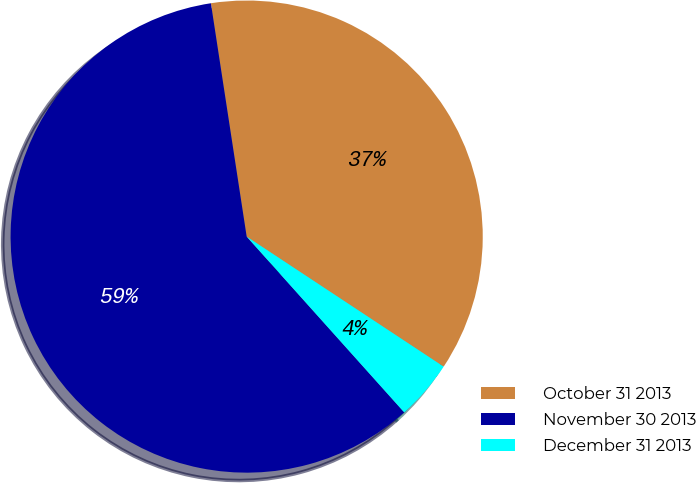<chart> <loc_0><loc_0><loc_500><loc_500><pie_chart><fcel>October 31 2013<fcel>November 30 2013<fcel>December 31 2013<nl><fcel>36.71%<fcel>59.21%<fcel>4.08%<nl></chart> 